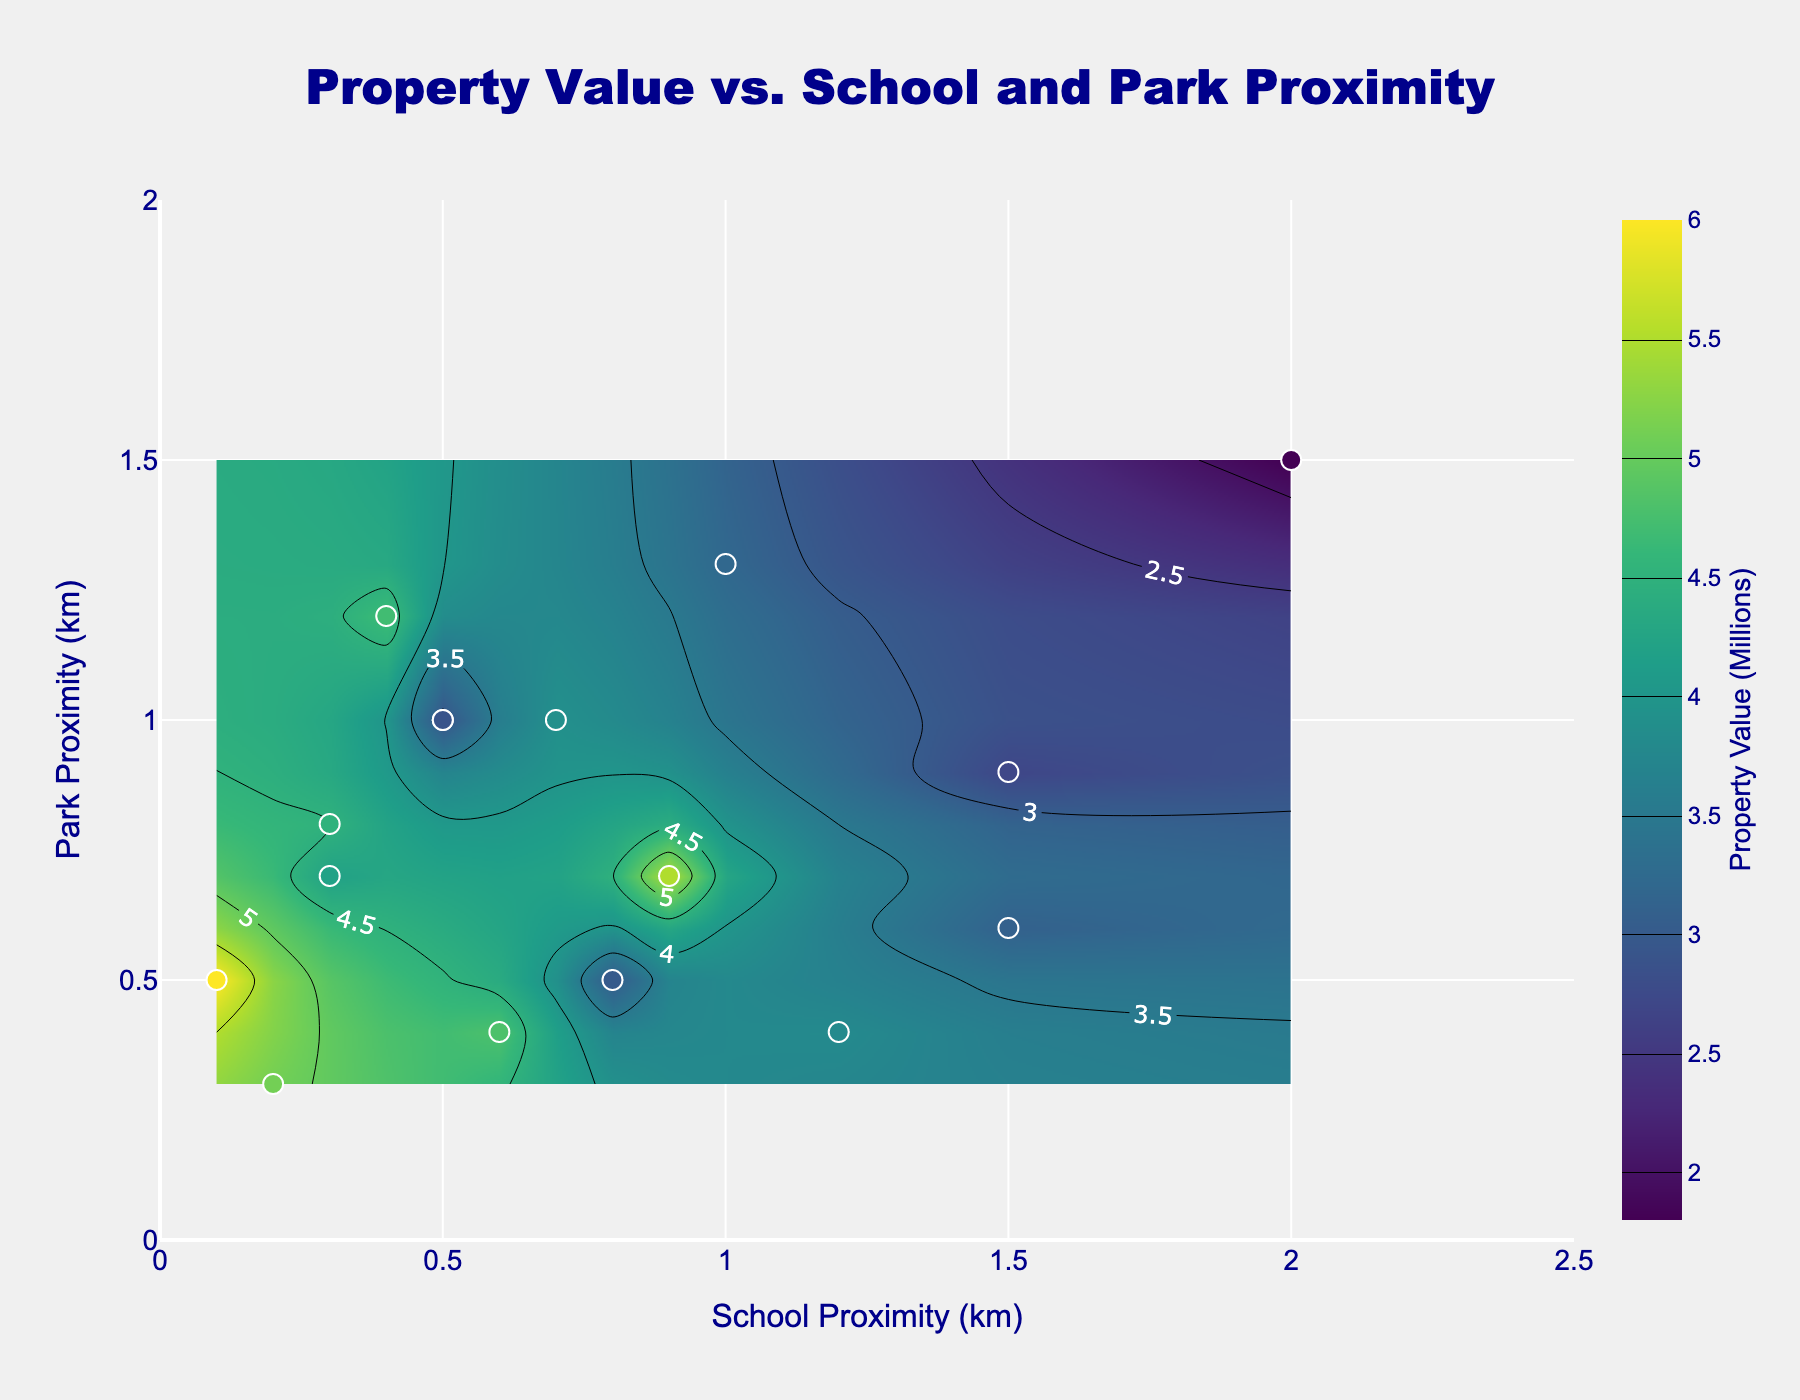What is the title of the plot? The title is displayed at the top center of the plot in large font. It reads, "Property Value vs. School and Park Proximity".
Answer: Property Value vs. School and Park Proximity How many data points are represented in the plot? Each data point is marked with a white-bordered dot on the plot. Counting these dots on the plot gives a total of 16 data points.
Answer: 16 What is the range of school proximity values shown on the x-axis? The x-axis represents school proximity in kilometers, with labels and tick marks indicating the range from 0 to 2.5 kilometers.
Answer: 0 to 2.5 km Are high-value properties generally closer to schools or parks? High-value properties, indicated by the highest contour levels and scatter colors, are clustered near lower values of school proximity (closer to the x-axis origin).
Answer: Closer to schools Which data point has the highest property value? The property with the highest value will be represented by a dark color and a label when hovering. Looking closely at the plot, the point around (0.1, 0.5) has the highest value of 6.0 million.
Answer: Property with coordinates (0.1, 0.5) Which property has the closest proximity to both schools and parks? The property closest to both schools and parks will have coordinates near the origin (0,0). The point at approximately (0.2, 0.3) represents this property.
Answer: Property with coordinates (0.2, 0.3) What is the park proximity range for properties valued above 5 million? Observing the contour levels and scatter colors corresponding to values above 5 million, as well as checking the legend, these properties have park proximities between approximately 0.3 and 1.2 km.
Answer: 0.3 to 1.2 km How does proximity to parks influence property value? Examining the contour plot, properties further from parks (y-axis higher values) generally have lower value contours, indicating that being closer to parks (lower y-axis values) is associated with higher property values.
Answer: Closer to parks increases value What's the average property value for locations within 0.5 km of both schools and parks? Identify data points within 0.5 km from both schools and parks, sum their values, and divide by the count: (2.5 + 3.0 + 4.2 + 5.1 + 6.0 + 4.7) / 6 = 25.5 / 6.
Answer: 4.25 million 